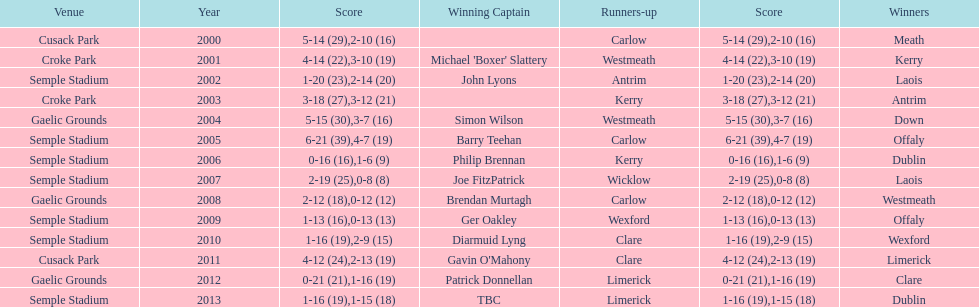Who was the first winner in 2013? Dublin. Would you mind parsing the complete table? {'header': ['Venue', 'Year', 'Score', 'Winning Captain', 'Runners-up', 'Score', 'Winners'], 'rows': [['Cusack Park', '2000', '5-14 (29)', '', 'Carlow', '2-10 (16)', 'Meath'], ['Croke Park', '2001', '4-14 (22)', "Michael 'Boxer' Slattery", 'Westmeath', '3-10 (19)', 'Kerry'], ['Semple Stadium', '2002', '1-20 (23)', 'John Lyons', 'Antrim', '2-14 (20)', 'Laois'], ['Croke Park', '2003', '3-18 (27)', '', 'Kerry', '3-12 (21)', 'Antrim'], ['Gaelic Grounds', '2004', '5-15 (30)', 'Simon Wilson', 'Westmeath', '3-7 (16)', 'Down'], ['Semple Stadium', '2005', '6-21 (39)', 'Barry Teehan', 'Carlow', '4-7 (19)', 'Offaly'], ['Semple Stadium', '2006', '0-16 (16)', 'Philip Brennan', 'Kerry', '1-6 (9)', 'Dublin'], ['Semple Stadium', '2007', '2-19 (25)', 'Joe FitzPatrick', 'Wicklow', '0-8 (8)', 'Laois'], ['Gaelic Grounds', '2008', '2-12 (18)', 'Brendan Murtagh', 'Carlow', '0-12 (12)', 'Westmeath'], ['Semple Stadium', '2009', '1-13 (16)', 'Ger Oakley', 'Wexford', '0-13 (13)', 'Offaly'], ['Semple Stadium', '2010', '1-16 (19)', 'Diarmuid Lyng', 'Clare', '2-9 (15)', 'Wexford'], ['Cusack Park', '2011', '4-12 (24)', "Gavin O'Mahony", 'Clare', '2-13 (19)', 'Limerick'], ['Gaelic Grounds', '2012', '0-21 (21)', 'Patrick Donnellan', 'Limerick', '1-16 (19)', 'Clare'], ['Semple Stadium', '2013', '1-16 (19)', 'TBC', 'Limerick', '1-15 (18)', 'Dublin']]} 